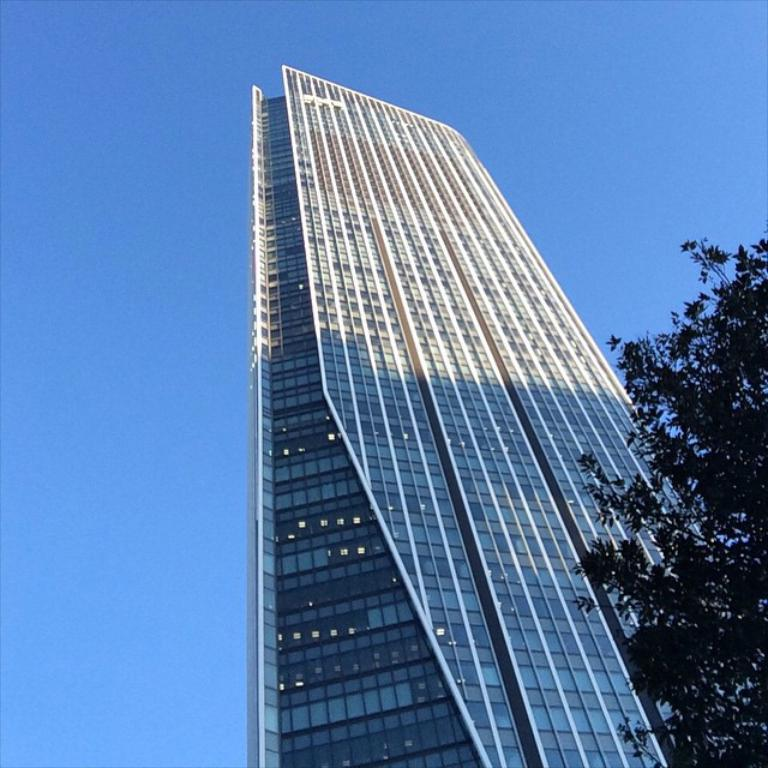What is the main structure in the image? There is a building in the image. What can be seen inside the building? There are lights visible in the building. What is visible in the background of the image? The sky is visible in the image. What type of vegetation is on the right side of the image? There is a tree on the right side of the image. How many ants can be seen crawling on the building in the image? There are no ants visible in the image; the focus is on the building, lights, sky, and tree. 